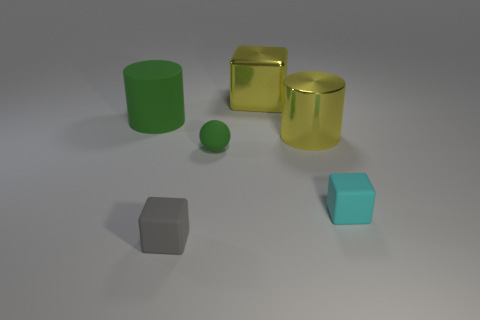Does the cube that is in front of the cyan thing have the same material as the green thing that is in front of the shiny cylinder?
Offer a terse response. Yes. There is another small rubber object that is the same shape as the cyan thing; what color is it?
Give a very brief answer. Gray. There is a green thing that is right of the large cylinder left of the tiny gray object; what is its material?
Your answer should be compact. Rubber. Do the yellow thing behind the large metal cylinder and the green matte object that is on the left side of the tiny green object have the same shape?
Your answer should be very brief. No. What size is the object that is both in front of the big yellow metal cylinder and behind the small cyan rubber thing?
Ensure brevity in your answer.  Small. What number of other objects are the same color as the metallic cylinder?
Provide a short and direct response. 1. Is the large thing that is to the right of the big yellow cube made of the same material as the big cube?
Keep it short and to the point. Yes. Is there any other thing that has the same size as the rubber ball?
Your answer should be compact. Yes. Is the number of small gray rubber things to the right of the green rubber cylinder less than the number of small matte spheres in front of the yellow cylinder?
Your answer should be compact. No. Are there any other things that are the same shape as the small gray matte thing?
Offer a terse response. Yes. 